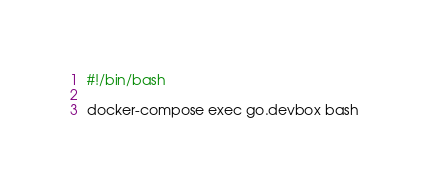Convert code to text. <code><loc_0><loc_0><loc_500><loc_500><_Bash_>#!/bin/bash

docker-compose exec go.devbox bash

</code> 